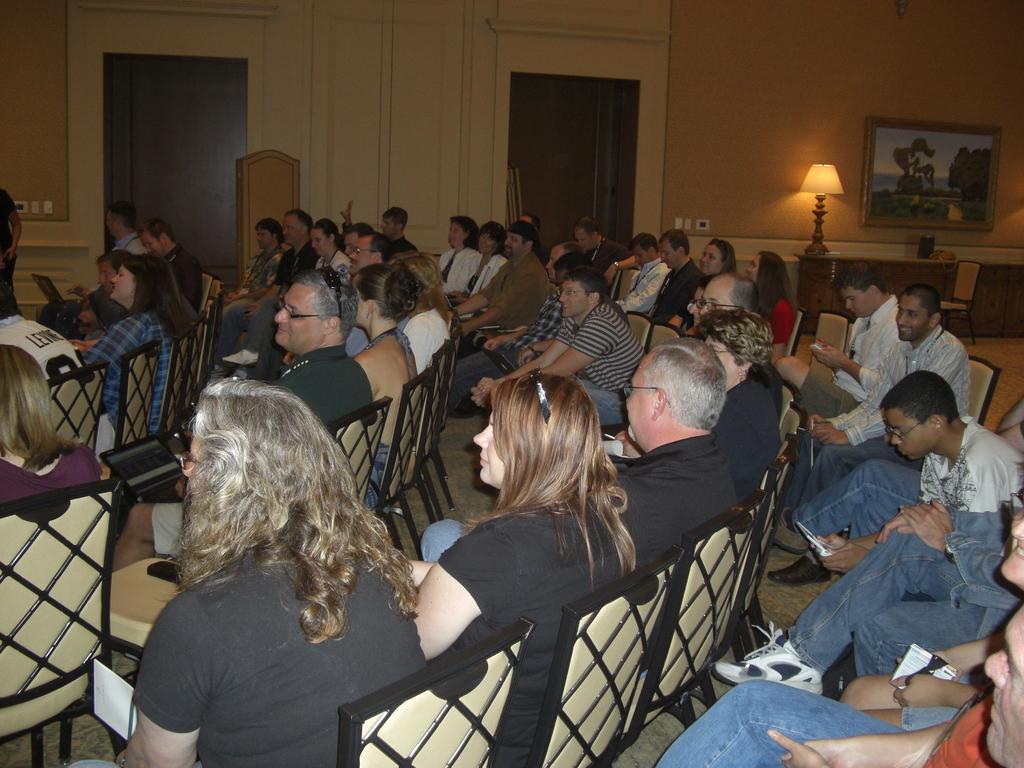Describe this image in one or two sentences. In this image I can see many people seated on the chairs, in a room. There is a lamp, photo frame and 2 doorways at the back. 